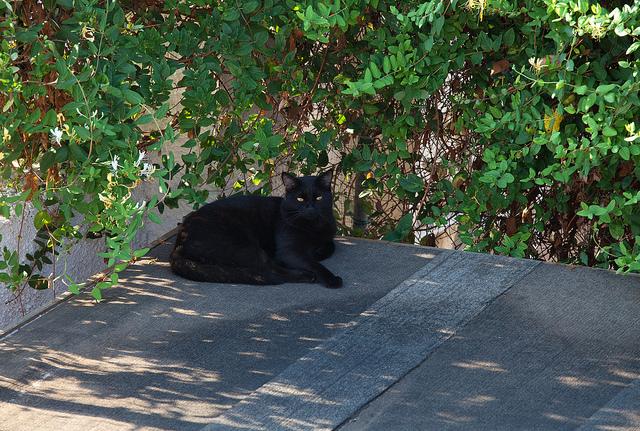Is the cat laying in the shade?
Concise answer only. Yes. Would this animal be an appropriate pet?
Keep it brief. Yes. Is it a sunny day?
Short answer required. Yes. What is the cat sitting on?
Give a very brief answer. Roof. Is the cat asleep?
Concise answer only. No. 